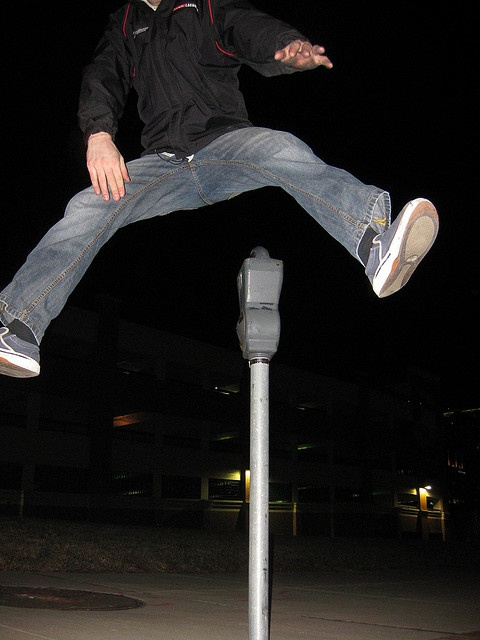Describe the objects in this image and their specific colors. I can see people in black, gray, and darkgray tones and parking meter in black and gray tones in this image. 